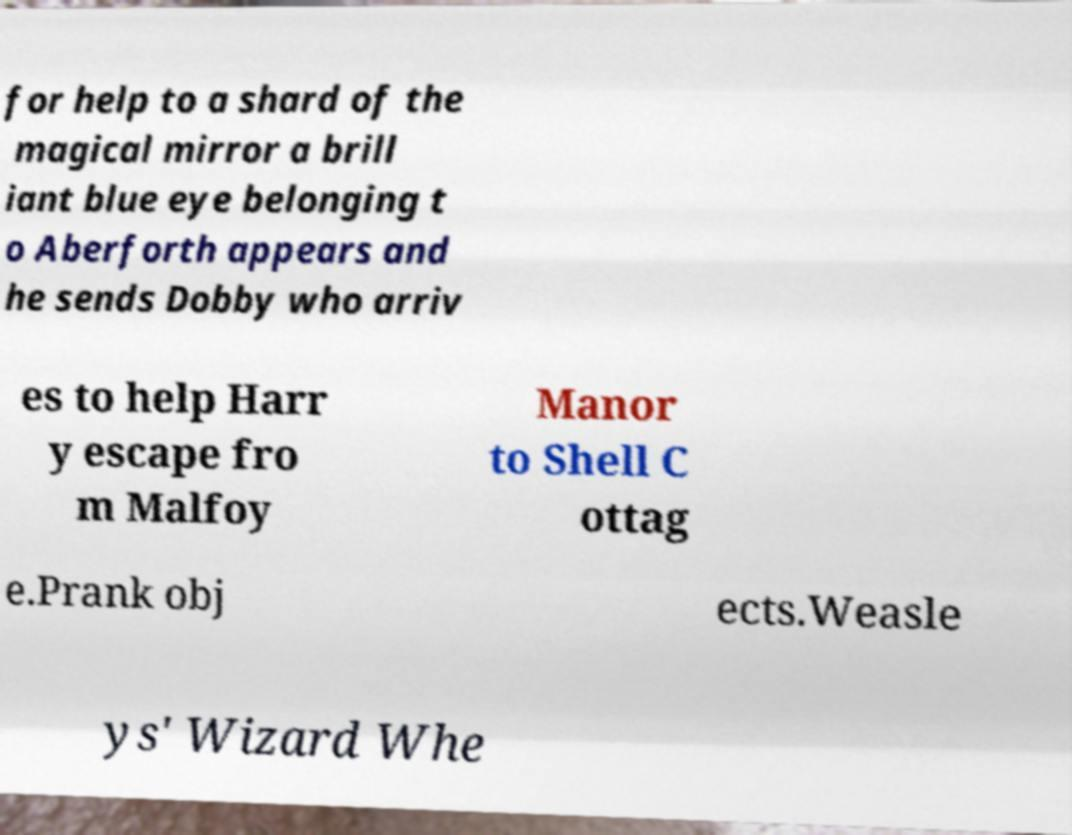Please identify and transcribe the text found in this image. for help to a shard of the magical mirror a brill iant blue eye belonging t o Aberforth appears and he sends Dobby who arriv es to help Harr y escape fro m Malfoy Manor to Shell C ottag e.Prank obj ects.Weasle ys' Wizard Whe 